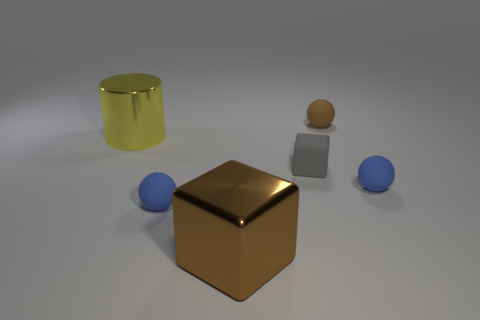Subtract 1 balls. How many balls are left? 2 Subtract all tiny blue spheres. How many spheres are left? 1 Add 4 brown cubes. How many objects exist? 10 Subtract all cylinders. How many objects are left? 5 Add 3 big shiny blocks. How many big shiny blocks exist? 4 Subtract 1 gray cubes. How many objects are left? 5 Subtract all blue spheres. Subtract all tiny gray objects. How many objects are left? 3 Add 3 big objects. How many big objects are left? 5 